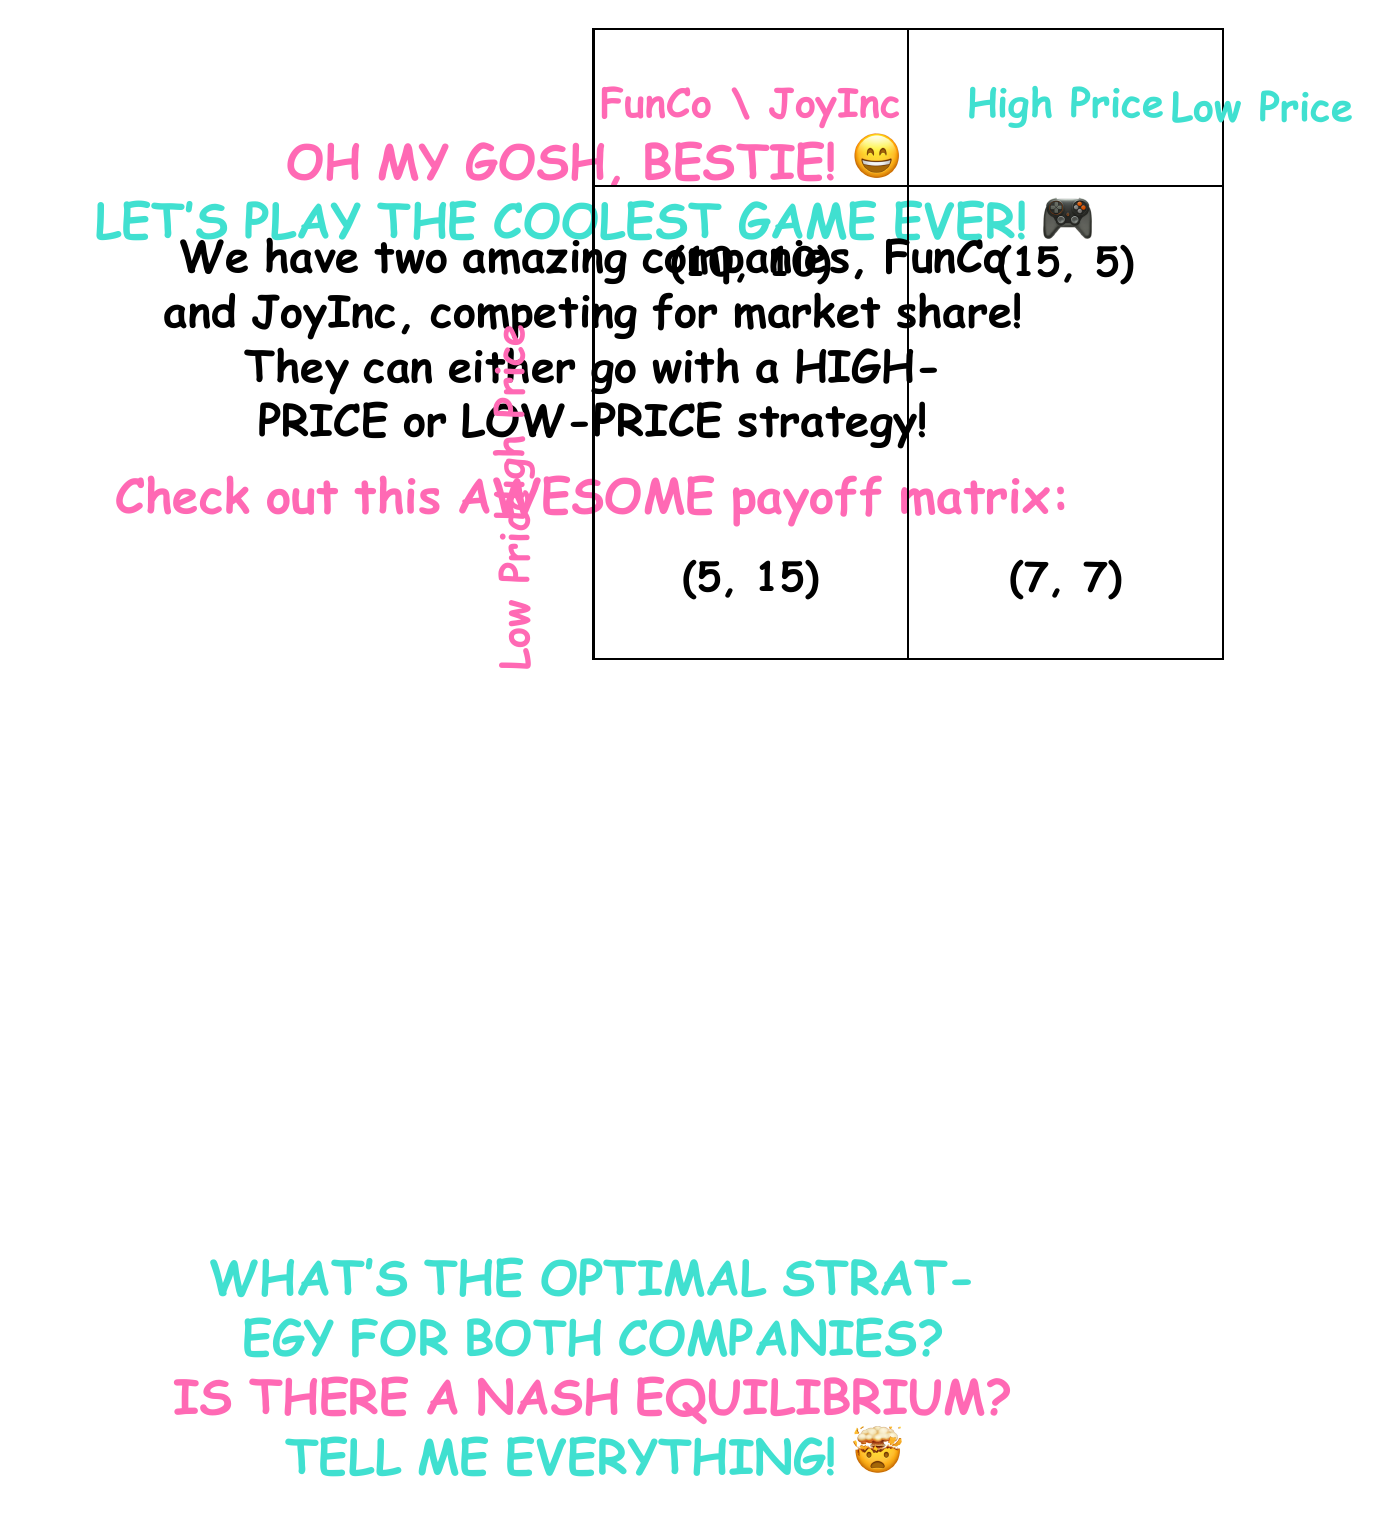Can you answer this question? Alright, bestie! Let's break this down step-by-step:

1) First, we need to understand what a Nash Equilibrium is. It's a situation where no player can unilaterally change their strategy to increase their payoff. 

2) Let's analyze each company's options:

   For FunCo:
   - If JoyInc chooses High Price, FunCo gets 10 with High Price and 15 with Low Price.
   - If JoyInc chooses Low Price, FunCo gets 5 with High Price and 7 with Low Price.

   For JoyInc:
   - If FunCo chooses High Price, JoyInc gets 10 with High Price and 15 with Low Price.
   - If FunCo chooses Low Price, JoyInc gets 5 with High Price and 7 with Low Price.

3) We can see that for both companies, regardless of what the other does, choosing Low Price always gives a higher payoff:

   For FunCo: 15 > 10 and 7 > 5
   For JoyInc: 15 > 10 and 7 > 5

4) This strategy is called a dominant strategy because it's always the best choice regardless of what the other player does.

5) Since both companies have Low Price as their dominant strategy, when they both choose Low Price, neither can unilaterally change their strategy to increase their payoff.

6) Therefore, (Low Price, Low Price) with payoffs (7, 7) is the Nash Equilibrium.

7) The optimal strategy for both companies is to choose Low Price.

8) Interestingly, if they could cooperate and both choose High Price, they would both be better off with payoffs (10, 10). However, the incentive to undercut each other leads to the Nash Equilibrium of (Low Price, Low Price).

This scenario is an example of the famous "Prisoner's Dilemma" in game theory!
Answer: Nash Equilibrium: (Low Price, Low Price) 